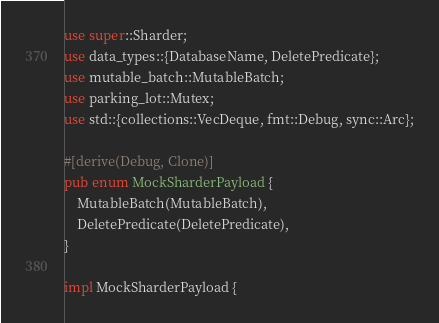Convert code to text. <code><loc_0><loc_0><loc_500><loc_500><_Rust_>use super::Sharder;
use data_types::{DatabaseName, DeletePredicate};
use mutable_batch::MutableBatch;
use parking_lot::Mutex;
use std::{collections::VecDeque, fmt::Debug, sync::Arc};

#[derive(Debug, Clone)]
pub enum MockSharderPayload {
    MutableBatch(MutableBatch),
    DeletePredicate(DeletePredicate),
}

impl MockSharderPayload {</code> 